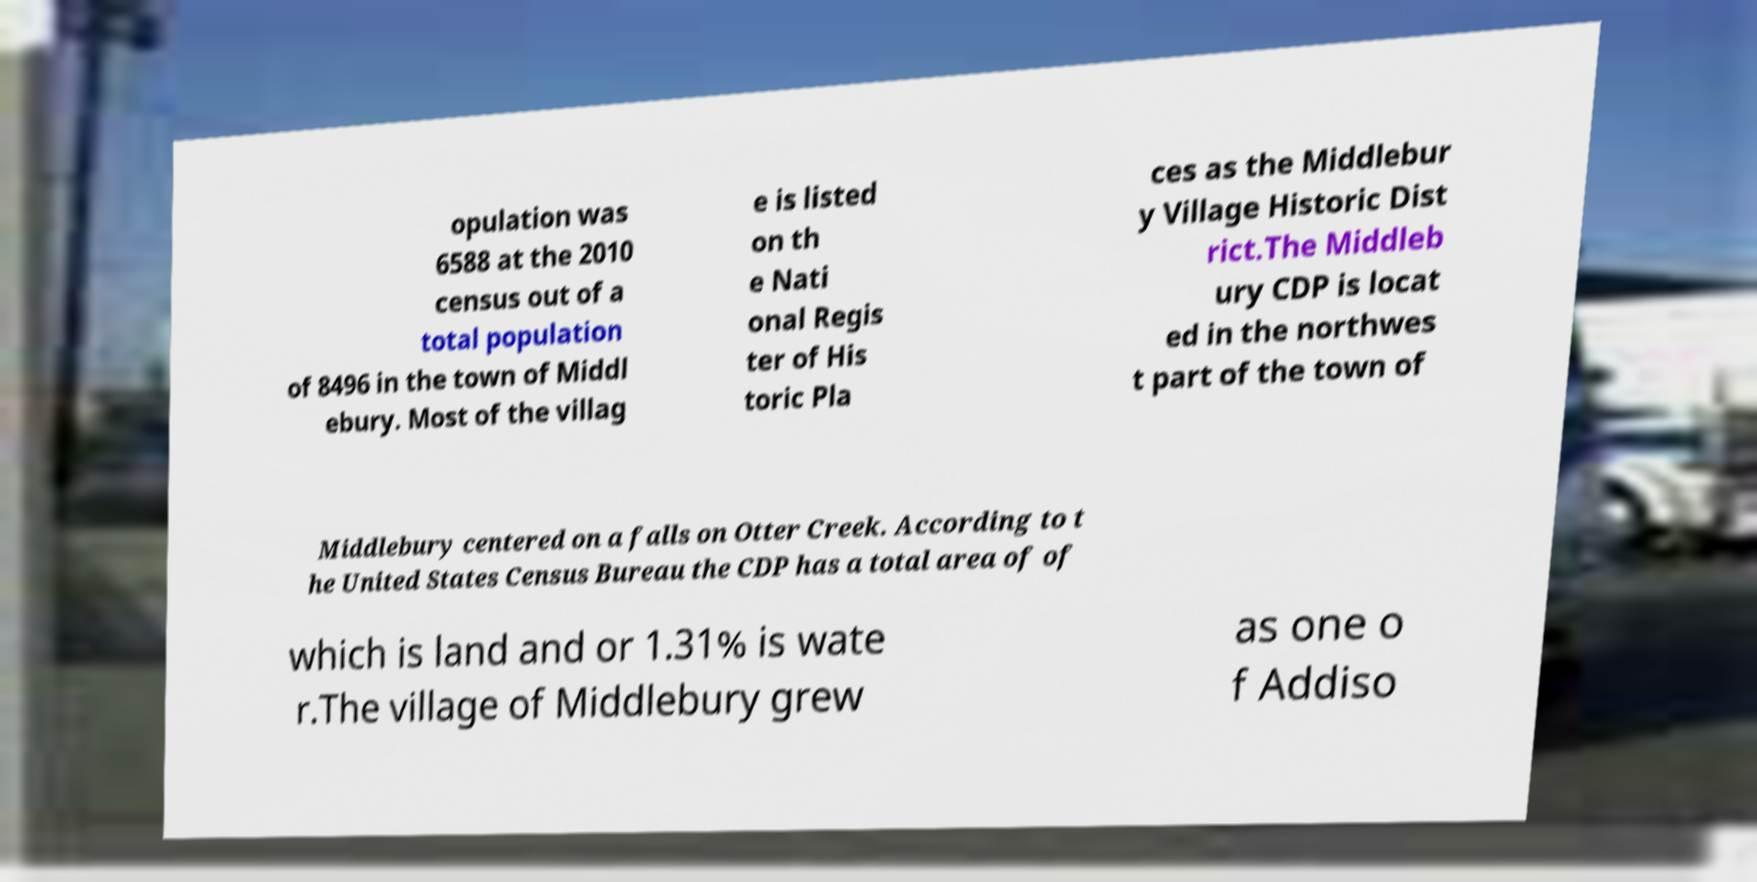Could you assist in decoding the text presented in this image and type it out clearly? opulation was 6588 at the 2010 census out of a total population of 8496 in the town of Middl ebury. Most of the villag e is listed on th e Nati onal Regis ter of His toric Pla ces as the Middlebur y Village Historic Dist rict.The Middleb ury CDP is locat ed in the northwes t part of the town of Middlebury centered on a falls on Otter Creek. According to t he United States Census Bureau the CDP has a total area of of which is land and or 1.31% is wate r.The village of Middlebury grew as one o f Addiso 